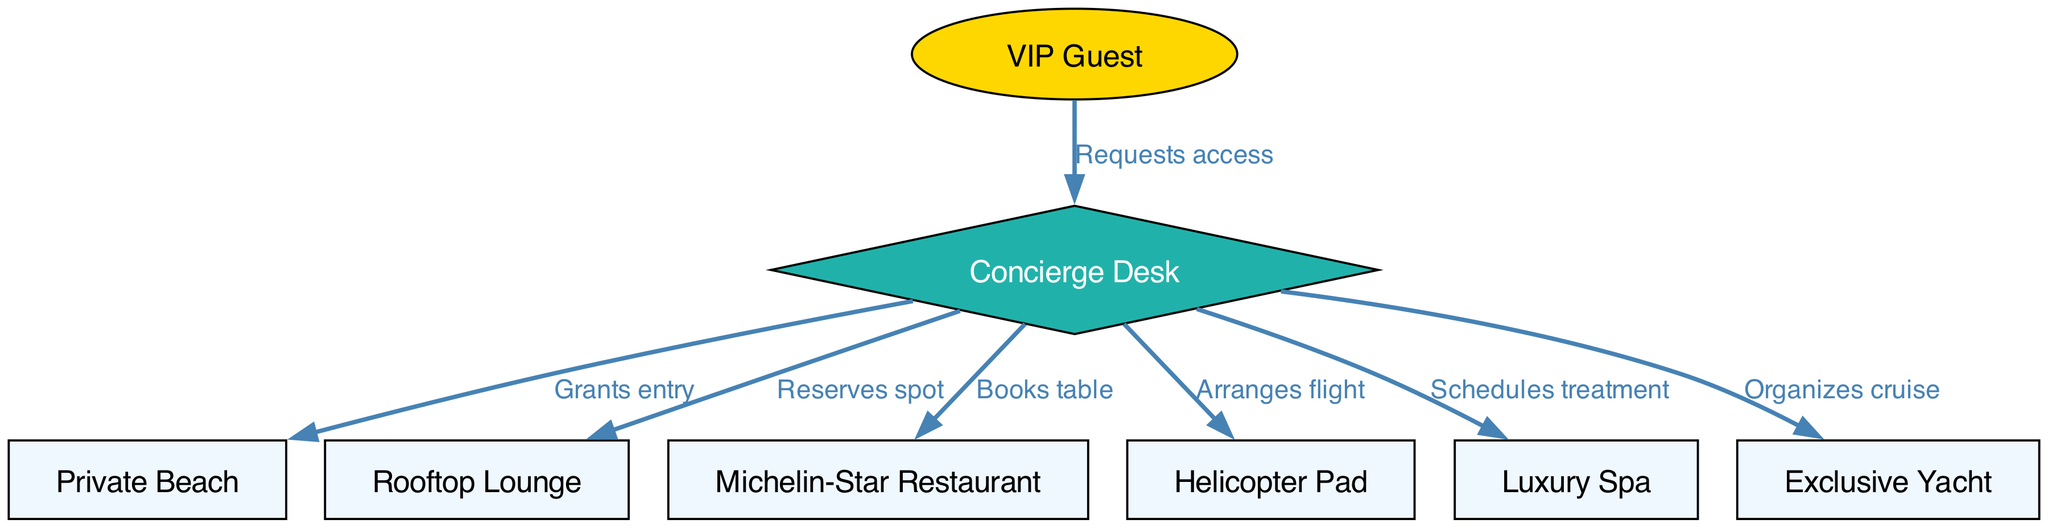What is the starting node in the diagram? The starting node is where the flow of access begins, which is indicated by the "VIP Guest." This node connects to the "Concierge Desk," thus representing the entry point for requests.
Answer: VIP Guest How many total nodes are present in the diagram? Counting all distinct entities in the diagram, we find there are eight nodes listed: VIP Guest, Concierge Desk, Private Beach, Rooftop Lounge, Michelin-Star Restaurant, Helicopter Pad, Luxury Spa, and Exclusive Yacht.
Answer: 8 Which node is directly connected to the Concierge Desk for dining reservations? The diagram specifies that the Concierge Desk has a directed edge labeled "Books table" leading to the "Michelin-Star Restaurant." This indicates that dining reservations are handled through this connection.
Answer: Michelin-Star Restaurant What type of node is the Concierge Desk? The Concierge Desk is uniquely shaped as a diamond in the diagram, indicating its special role in granting access and facilitating various experiences, differentiating it from other nodes.
Answer: Diamond Which exclusive experience can a VIP Guest gain by interacting with the Concierge Desk? By making requests at the Concierge Desk, a VIP Guest can gain access to several exclusive experiences such as booking a table at the Michelin-Star Restaurant, reserving a spot at the Rooftop Lounge, or arranging a flight from the Helicopter Pad. The activities demonstrate the Concierge Desk's role as a facilitator for multiple experiences.
Answer: Multiple What is the primary function of the edges originating from the Concierge Desk? The edges originating from the Concierge Desk all denote actions taken to facilitate access or reservations. This includes granting entry, reserving spots, or scheduling treatments, demonstrating the Concierge's role in managing luxury experiences.
Answer: Facilitate access Which node represents a luxury outdoor experience accessible to VIP Guests? The Private Beach node directly connects to the Concierge Desk, which suggests it offers an outdoor luxury experience for VIP Guests. Furthermore, it is a significant amenity highlighted in high-end resort offerings.
Answer: Private Beach How many exclusive experiences can the Concierge Desk organize for a VIP Guest? By analyzing the edges leading outward from the Concierge Desk, there are six exclusive experiences listed: Private Beach, Rooftop Lounge, Michelin-Star Restaurant, Helicopter Pad, Luxury Spa, and Exclusive Yacht, meaning the Concierge can organize six distinct experiences.
Answer: 6 